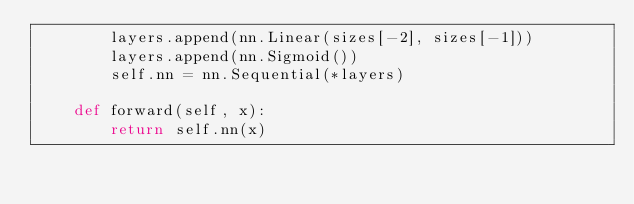<code> <loc_0><loc_0><loc_500><loc_500><_Python_>        layers.append(nn.Linear(sizes[-2], sizes[-1]))
        layers.append(nn.Sigmoid())
        self.nn = nn.Sequential(*layers)

    def forward(self, x):
        return self.nn(x)</code> 